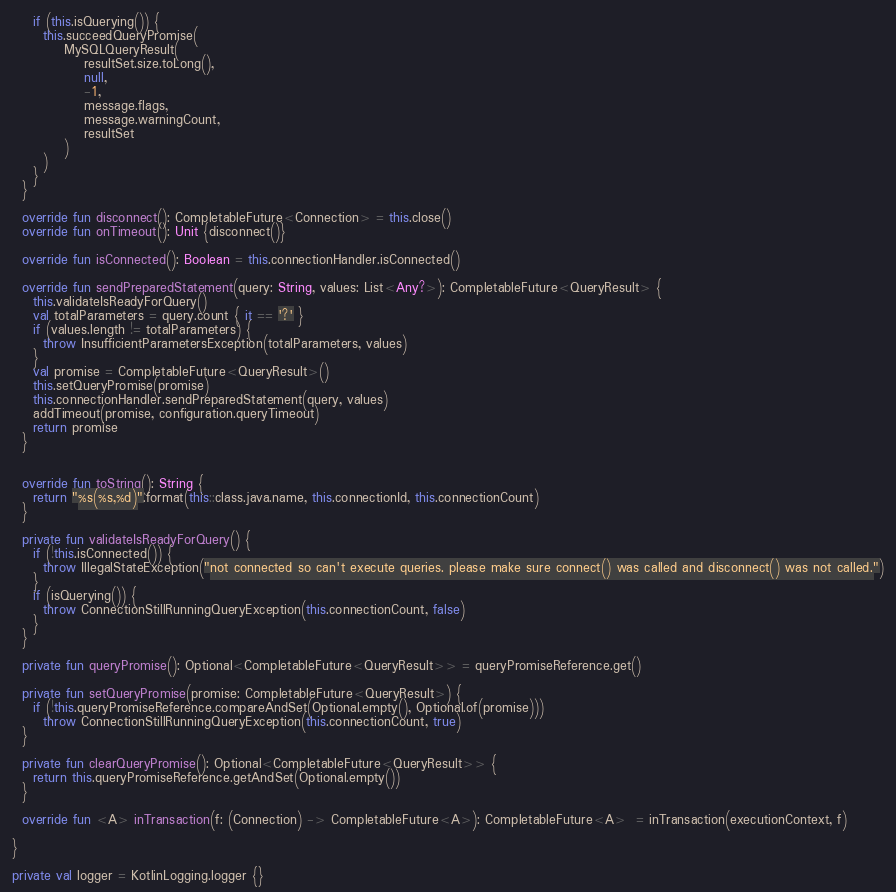Convert code to text. <code><loc_0><loc_0><loc_500><loc_500><_Kotlin_>    if (this.isQuerying()) {
      this.succeedQueryPromise(
          MySQLQueryResult(
              resultSet.size.toLong(),
              null,
              -1,
              message.flags,
              message.warningCount,
              resultSet
          )
      )
    }
  }

  override fun disconnect(): CompletableFuture<Connection> = this.close()
  override fun onTimeout(): Unit {disconnect()}

  override fun isConnected(): Boolean = this.connectionHandler.isConnected()

  override fun sendPreparedStatement(query: String, values: List<Any?>): CompletableFuture<QueryResult> {
    this.validateIsReadyForQuery()
    val totalParameters = query.count { it == '?' }
    if (values.length != totalParameters) {
      throw InsufficientParametersException(totalParameters, values)
    }
    val promise = CompletableFuture<QueryResult>()
    this.setQueryPromise(promise)
    this.connectionHandler.sendPreparedStatement(query, values)
    addTimeout(promise, configuration.queryTimeout)
    return promise
  }


  override fun toString(): String {
    return "%s(%s,%d)".format(this::class.java.name, this.connectionId, this.connectionCount)
  }

  private fun validateIsReadyForQuery() {
    if (!this.isConnected()) {
      throw IllegalStateException("not connected so can't execute queries. please make sure connect() was called and disconnect() was not called.")
    }
    if (isQuerying()) {
      throw ConnectionStillRunningQueryException(this.connectionCount, false)
    }
  }

  private fun queryPromise(): Optional<CompletableFuture<QueryResult>> = queryPromiseReference.get()

  private fun setQueryPromise(promise: CompletableFuture<QueryResult>) {
    if (!this.queryPromiseReference.compareAndSet(Optional.empty(), Optional.of(promise)))
      throw ConnectionStillRunningQueryException(this.connectionCount, true)
  }

  private fun clearQueryPromise(): Optional<CompletableFuture<QueryResult>> {
    return this.queryPromiseReference.getAndSet(Optional.empty())
  }

  override fun <A> inTransaction(f: (Connection) -> CompletableFuture<A>): CompletableFuture<A>  = inTransaction(executionContext, f)

}

private val logger = KotlinLogging.logger {}
</code> 